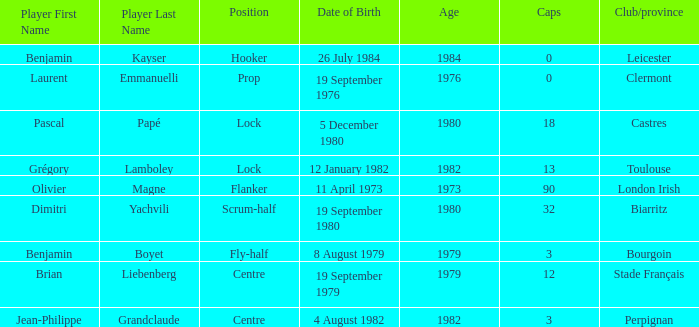What is the celebration day of 32-sized caps? 19 September 1980. 